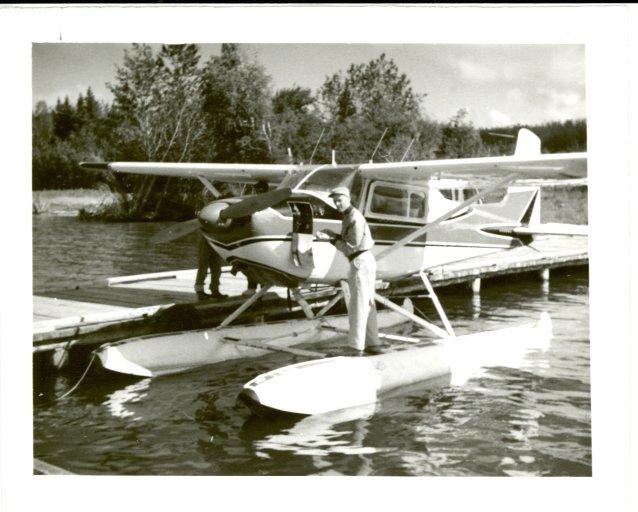What is the man standing on?
Quick response, please. Plane. How could you cross the river if you were walking?
Quick response, please. Boat. Is this a land vehicle?
Short answer required. No. What type of vehicle is in the photo?
Concise answer only. Plane. 